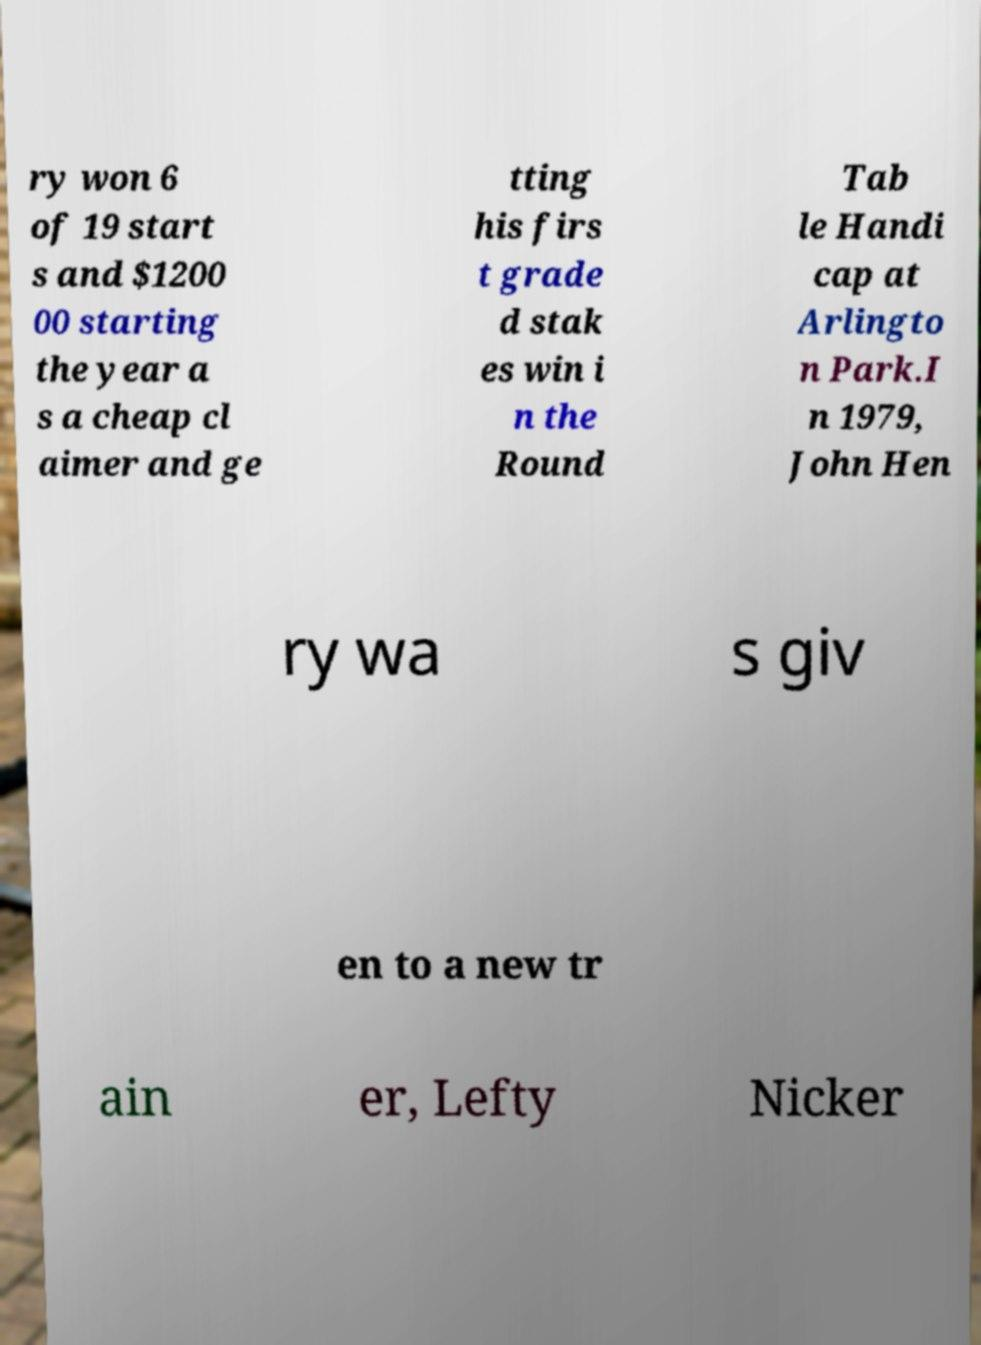I need the written content from this picture converted into text. Can you do that? ry won 6 of 19 start s and $1200 00 starting the year a s a cheap cl aimer and ge tting his firs t grade d stak es win i n the Round Tab le Handi cap at Arlingto n Park.I n 1979, John Hen ry wa s giv en to a new tr ain er, Lefty Nicker 